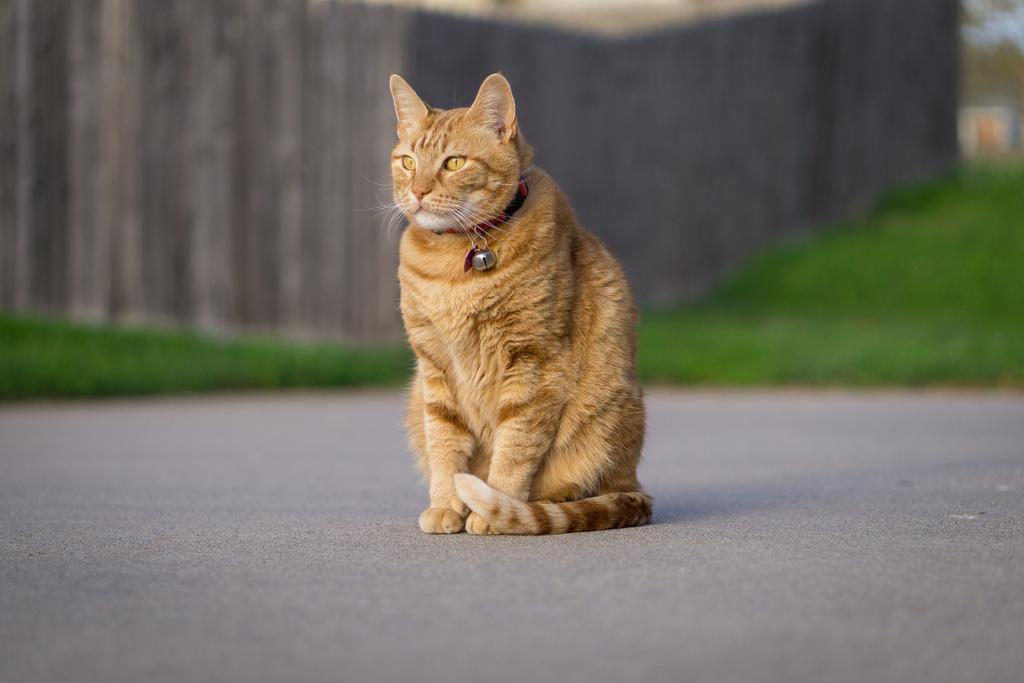In one or two sentences, can you explain what this image depicts? In this image, we can see a cat is sitting on the road. Background it is a blur view. Here we can see green color. 